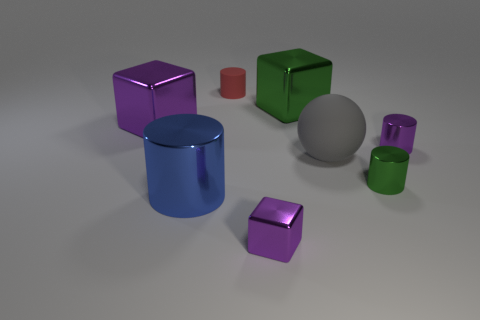Subtract all yellow balls. Subtract all purple blocks. How many balls are left? 1 Add 2 tiny gray cylinders. How many objects exist? 10 Subtract all balls. How many objects are left? 7 Add 6 large blocks. How many large blocks exist? 8 Subtract 0 cyan spheres. How many objects are left? 8 Subtract all tiny green things. Subtract all blue metal things. How many objects are left? 6 Add 3 tiny rubber cylinders. How many tiny rubber cylinders are left? 4 